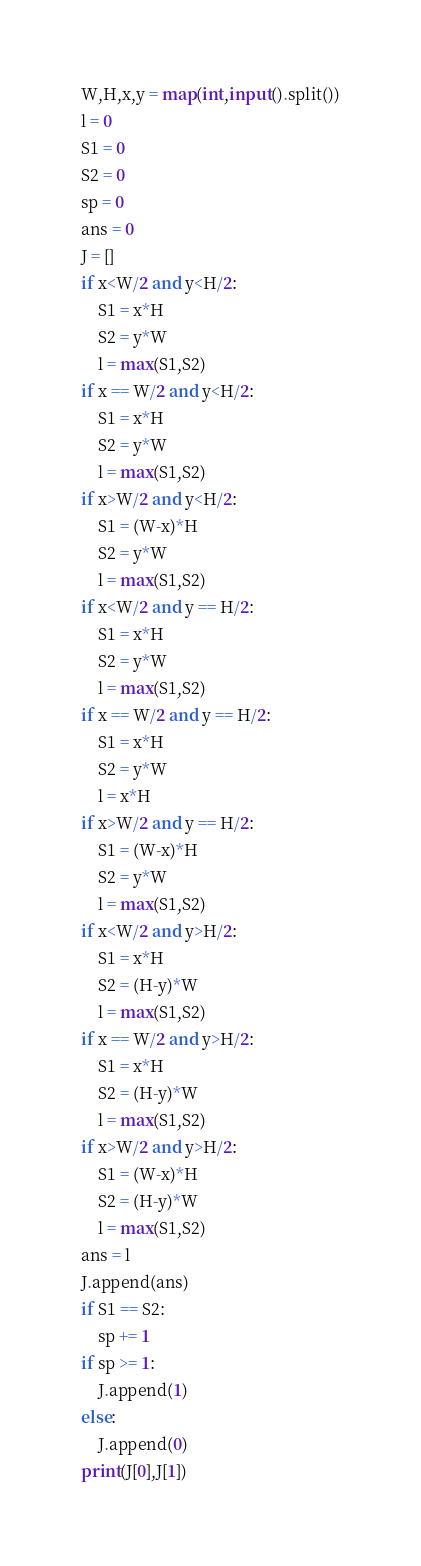<code> <loc_0><loc_0><loc_500><loc_500><_Python_>W,H,x,y = map(int,input().split())
l = 0
S1 = 0
S2 = 0
sp = 0
ans = 0
J = []
if x<W/2 and y<H/2:
    S1 = x*H
    S2 = y*W
    l = max(S1,S2)
if x == W/2 and y<H/2:
    S1 = x*H
    S2 = y*W
    l = max(S1,S2)
if x>W/2 and y<H/2:
    S1 = (W-x)*H
    S2 = y*W
    l = max(S1,S2)
if x<W/2 and y == H/2:
    S1 = x*H
    S2 = y*W
    l = max(S1,S2)
if x == W/2 and y == H/2:
    S1 = x*H
    S2 = y*W
    l = x*H
if x>W/2 and y == H/2:
    S1 = (W-x)*H
    S2 = y*W
    l = max(S1,S2)
if x<W/2 and y>H/2:
    S1 = x*H
    S2 = (H-y)*W
    l = max(S1,S2)
if x == W/2 and y>H/2:
    S1 = x*H
    S2 = (H-y)*W
    l = max(S1,S2)
if x>W/2 and y>H/2:
    S1 = (W-x)*H
    S2 = (H-y)*W
    l = max(S1,S2)
ans = l
J.append(ans)
if S1 == S2:
    sp += 1
if sp >= 1:
    J.append(1)
else:
    J.append(0)
print(J[0],J[1])</code> 